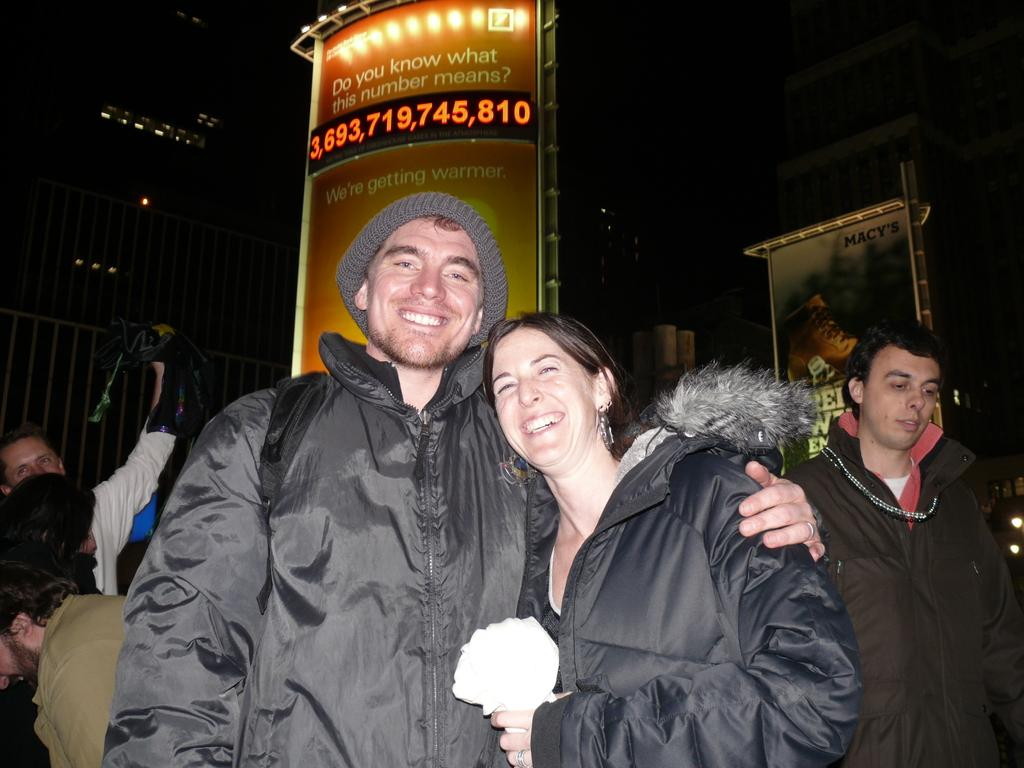How many people are present in the image? There are two people, a man and a woman, present in the image. What expressions do the man and the woman have? Both the man and the woman are smiling in the image. What can be seen in the background of the image? In the background of the image, there are people, posters, lights, a fence, and other objects. How would you describe the lighting in the background of the image? The background of the image is dark, with lights visible. How does the top of the fence move in the image? There is no indication of movement in the image, and the fence is not described as having a top that can move. 